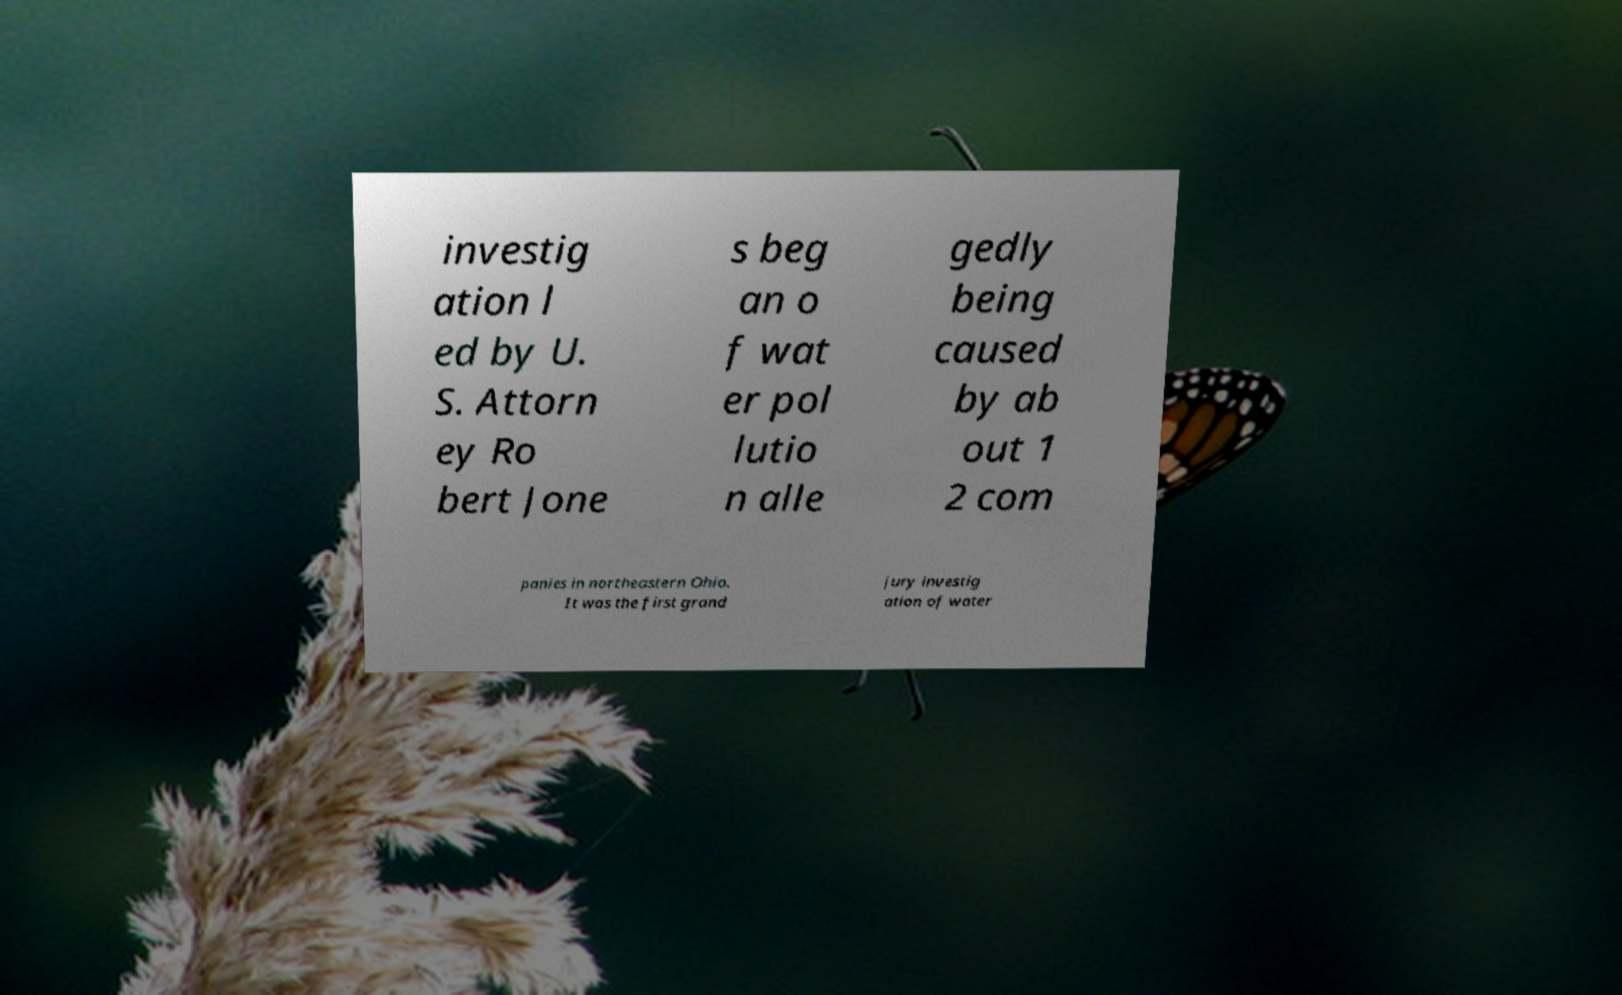Please read and relay the text visible in this image. What does it say? investig ation l ed by U. S. Attorn ey Ro bert Jone s beg an o f wat er pol lutio n alle gedly being caused by ab out 1 2 com panies in northeastern Ohio. It was the first grand jury investig ation of water 